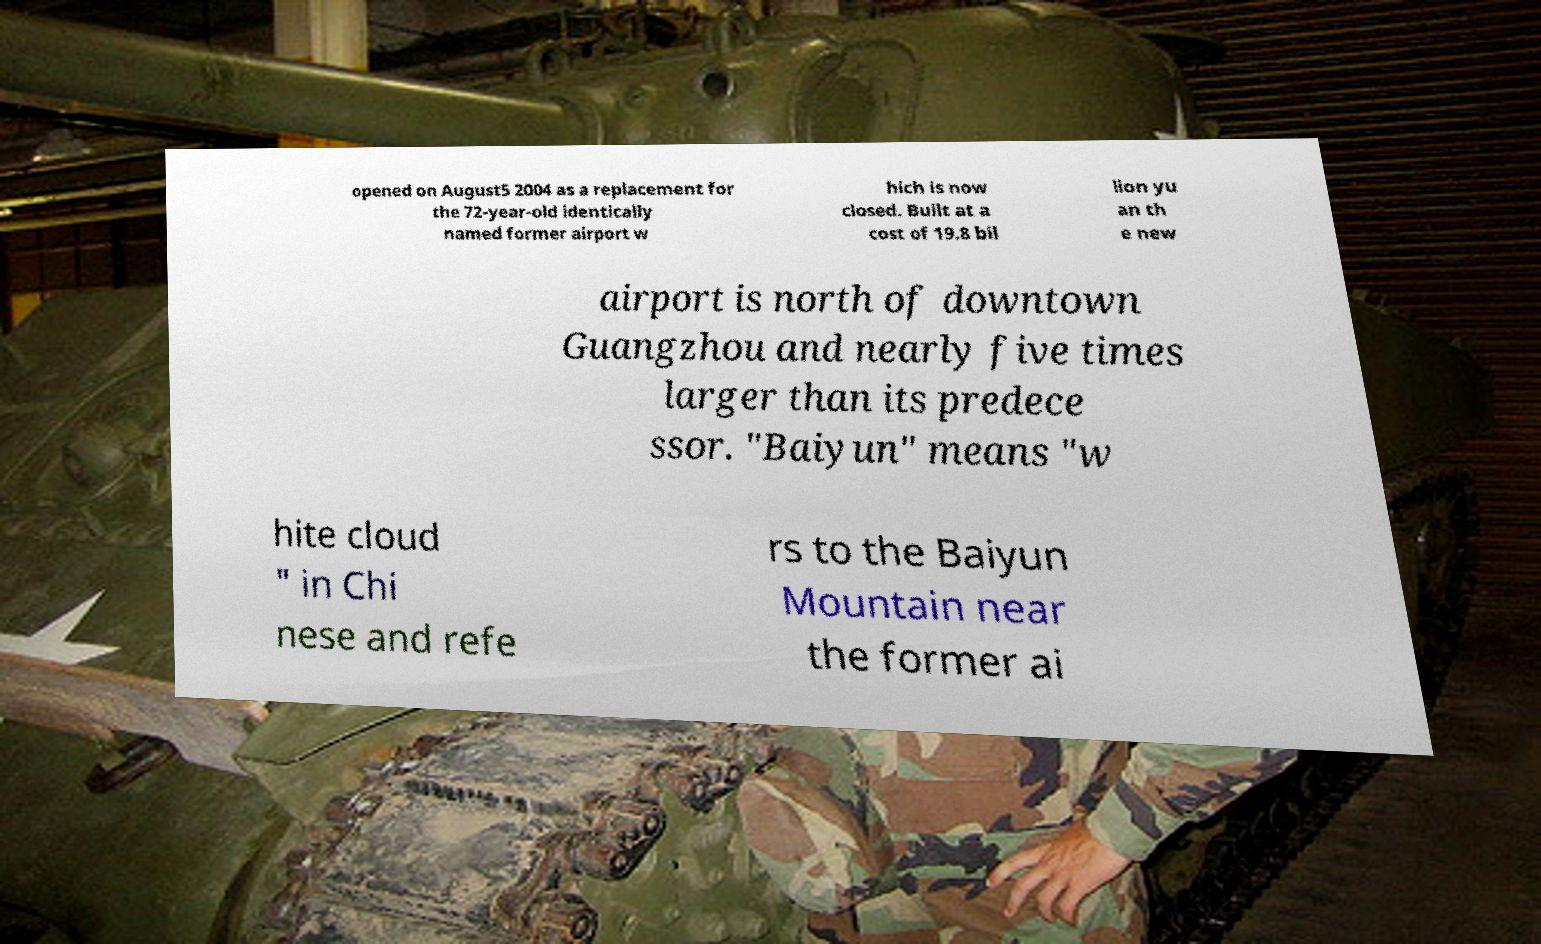Can you read and provide the text displayed in the image?This photo seems to have some interesting text. Can you extract and type it out for me? opened on August5 2004 as a replacement for the 72-year-old identically named former airport w hich is now closed. Built at a cost of 19.8 bil lion yu an th e new airport is north of downtown Guangzhou and nearly five times larger than its predece ssor. "Baiyun" means "w hite cloud " in Chi nese and refe rs to the Baiyun Mountain near the former ai 